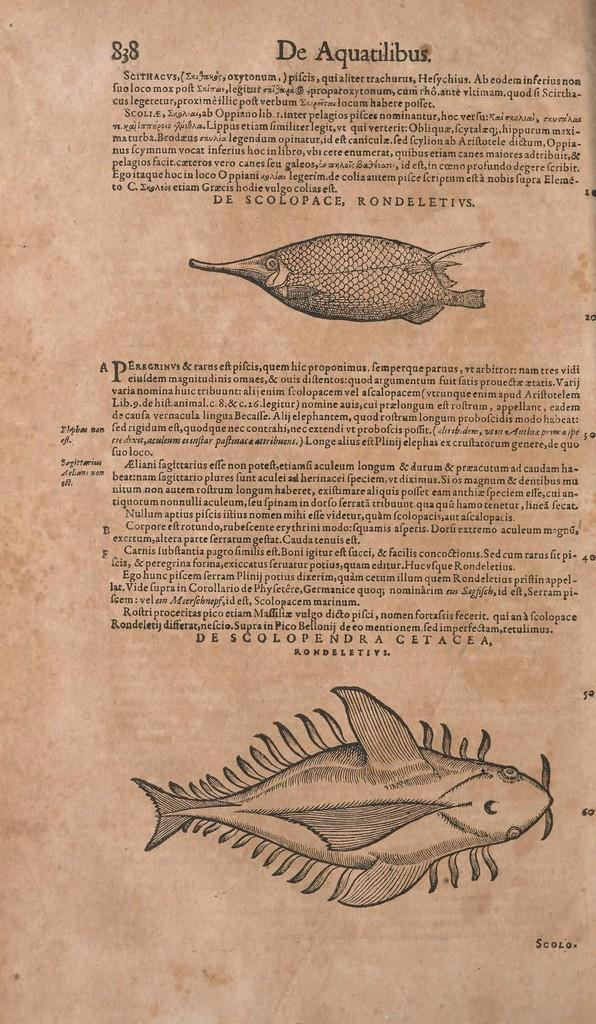What is depicted on the paper in the image? There are two types of fish drawings on paper. What else can be seen in the image besides the fish drawings? There is text visible in the image. What type of clam is shown in the image? There is no clam present in the image; it features two types of fish drawings and text. How does the elbow appear in the image? There is no elbow present in the image. 